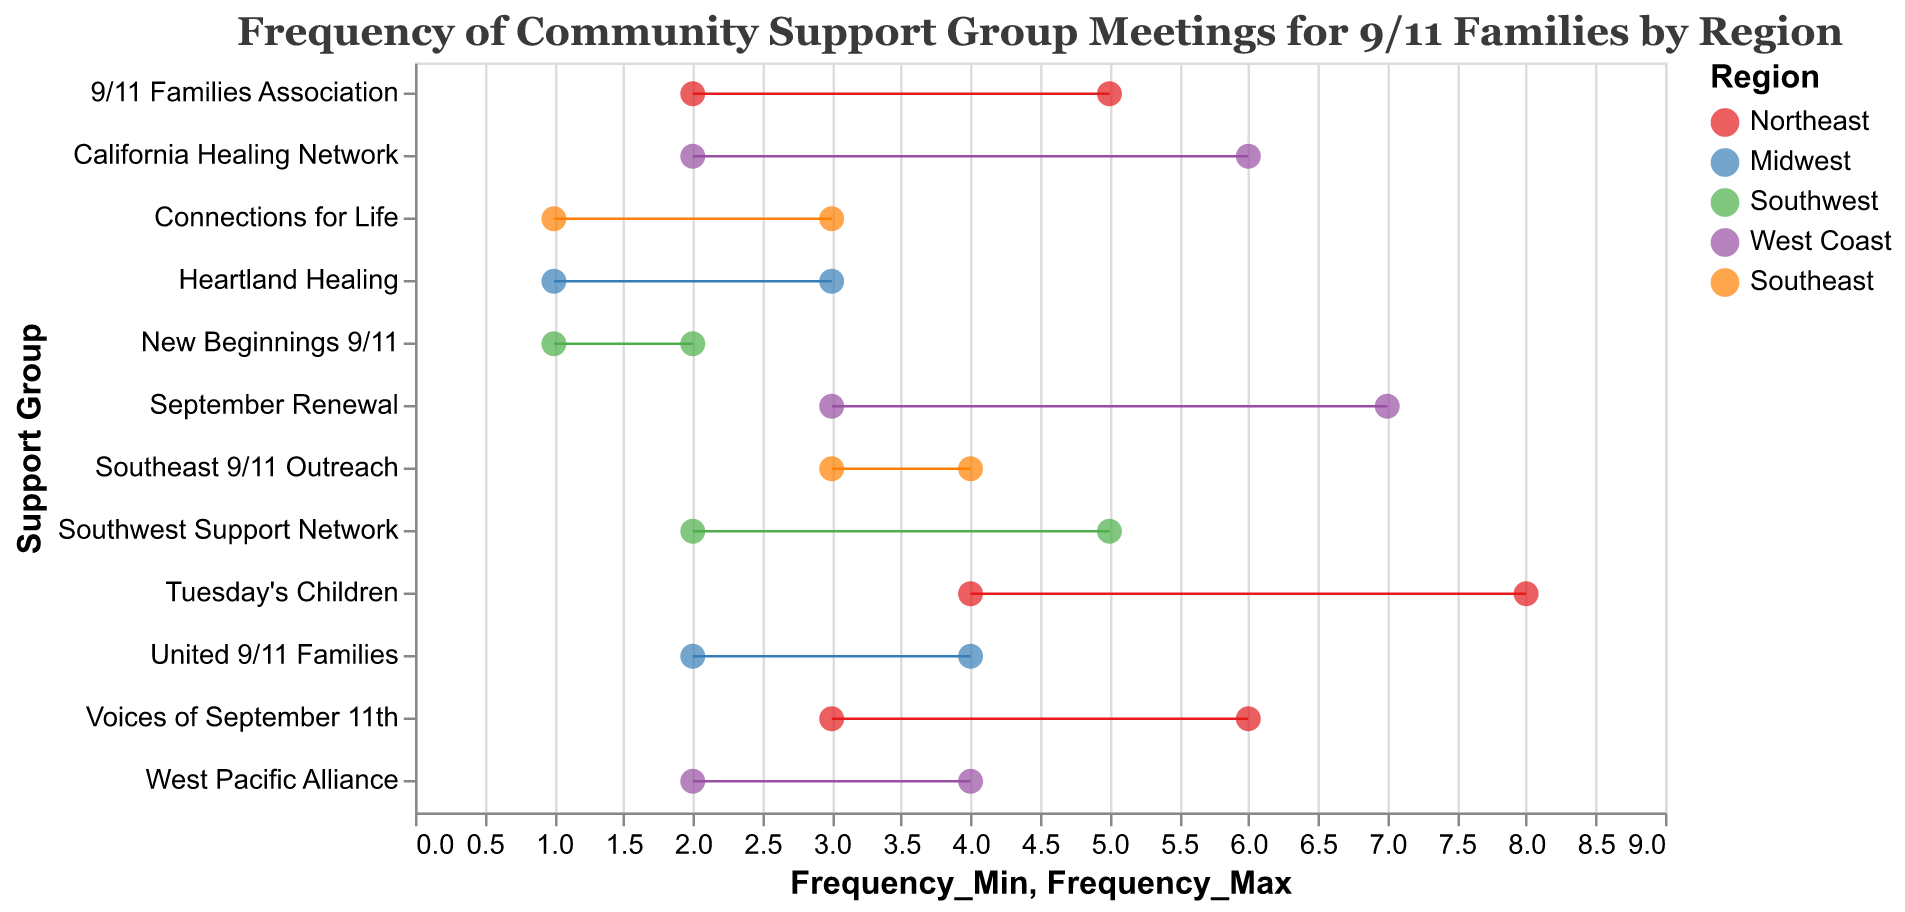What's the highest frequency range for support group meetings in the Northeast? Look for the support group in the Northeast region with the highest maximum frequency. Tuesday's Children ranges from 4 to 8.
Answer: 4 to 8 Which support group in the West Coast has the widest range of meeting frequencies? Look for the group with the largest difference between the minimum and maximum frequencies in the West Coast. California Healing Network ranges from 2 to 6 (a range of 4).
Answer: California Healing Network How many support groups from the Southeast region are shown in the plot? Count the number of unique support groups listed under the Southeast region.
Answer: 2 What is the minimum and maximum frequency for the "Southwest Support Network"? Locate the "Southwest Support Network" and identify its range values. The range is from 2 to 5.
Answer: 2 to 5 Among "New Beginnings 9/11" and "Connections for Life", which has the lower maximum frequency? Compare the maximum frequency values of "New Beginnings 9/11" (2) and "Connections for Life" (3). New Beginnings 9/11 has the lower maximum frequency.
Answer: New Beginnings 9/11 What is the average frequency range for the "Heartland Healing" support group? The range for "Heartland Healing" is from 1 to 3. The average is calculated as (1 + 3) / 2 = 2.
Answer: 2 Which region has the support group with the smallest range of meeting frequencies? Find the smallest range by subtracting the minimum frequency from the maximum for each group. This smallest range is 1, belonging to "New Beginnings 9/11" in the Southwest region.
Answer: Southwest Compare the frequency ranges of support groups in the Northeast to determine the group with the smallest range. Look at the differences between the max and min frequencies for each Northeast group. "9/11 Families Association" ranges from 2 to 5, a range of 3, which is the smallest.
Answer: 9/11 Families Association In which region is the support group "West Pacific Alliance" located, and what is its frequency range? Identify the region for "West Pacific Alliance," which is the West Coast, and then find its frequency range of 2 to 4.
Answer: West Coast; 2 to 4 